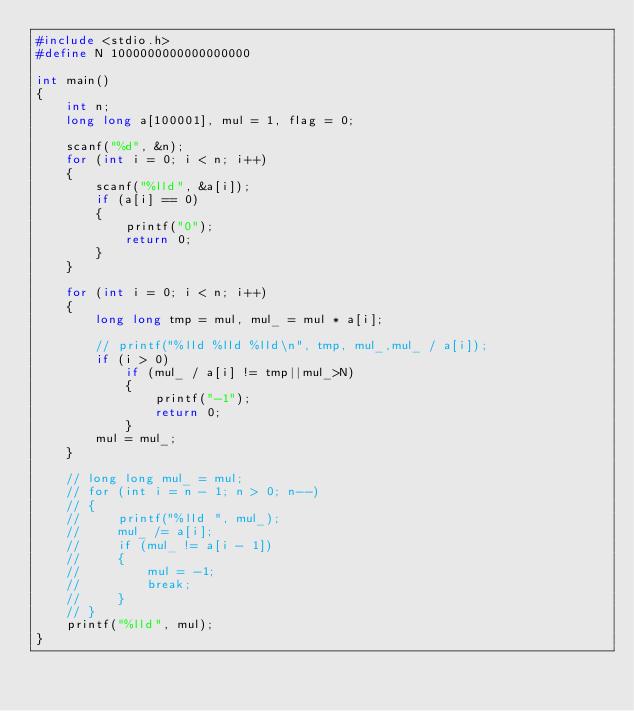Convert code to text. <code><loc_0><loc_0><loc_500><loc_500><_C_>#include <stdio.h>
#define N 1000000000000000000

int main()
{
    int n;
    long long a[100001], mul = 1, flag = 0;

    scanf("%d", &n);
    for (int i = 0; i < n; i++)
    {
        scanf("%lld", &a[i]);
        if (a[i] == 0)
        {
            printf("0");
            return 0;
        }
    }

    for (int i = 0; i < n; i++)
    {
        long long tmp = mul, mul_ = mul * a[i];

        // printf("%lld %lld %lld\n", tmp, mul_,mul_ / a[i]);
        if (i > 0)
            if (mul_ / a[i] != tmp||mul_>N)
            {
                printf("-1");
                return 0;
            }
        mul = mul_;
    }

    // long long mul_ = mul;
    // for (int i = n - 1; n > 0; n--)
    // {
    //     printf("%lld ", mul_);
    //     mul_ /= a[i];
    //     if (mul_ != a[i - 1])
    //     {
    //         mul = -1;
    //         break;
    //     }
    // }
    printf("%lld", mul);
}</code> 